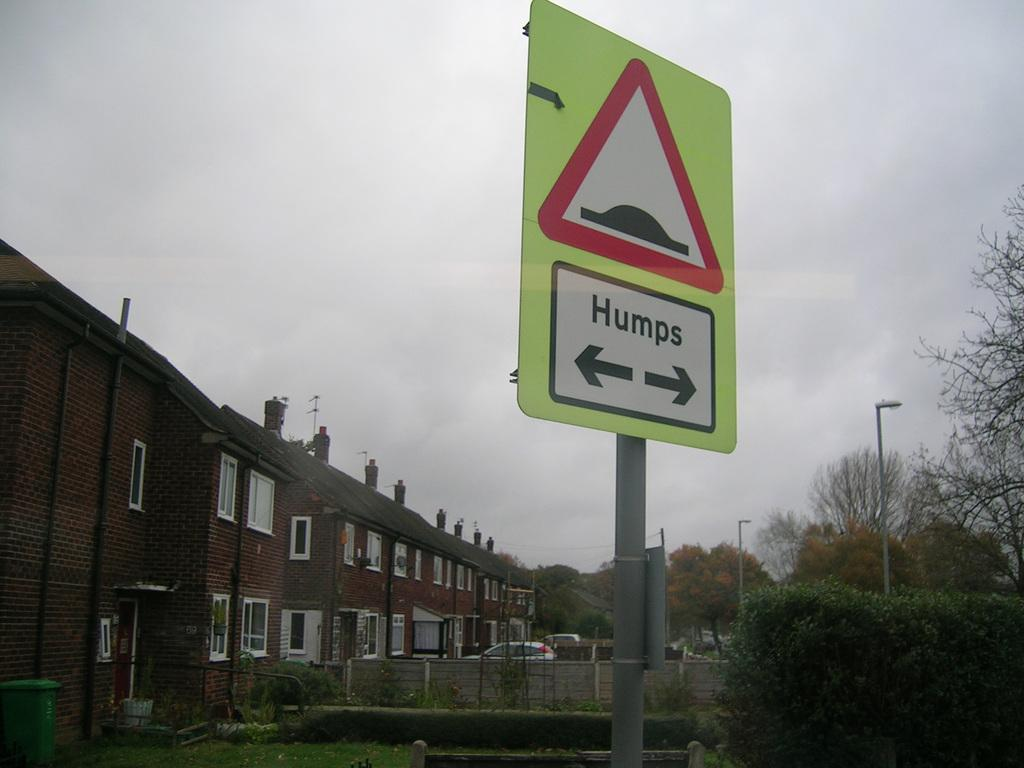What structures are located on the left side of the image? There are buildings on the left side of the image. What can be seen in the background of the image? There are vehicles, trees, and street lamps in the background of the image. What is visible at the top of the image? The sky is visible at the top of the image. How many legs can be seen on the straw in the image? There is no straw present in the image, so it is not possible to determine the number of legs. 